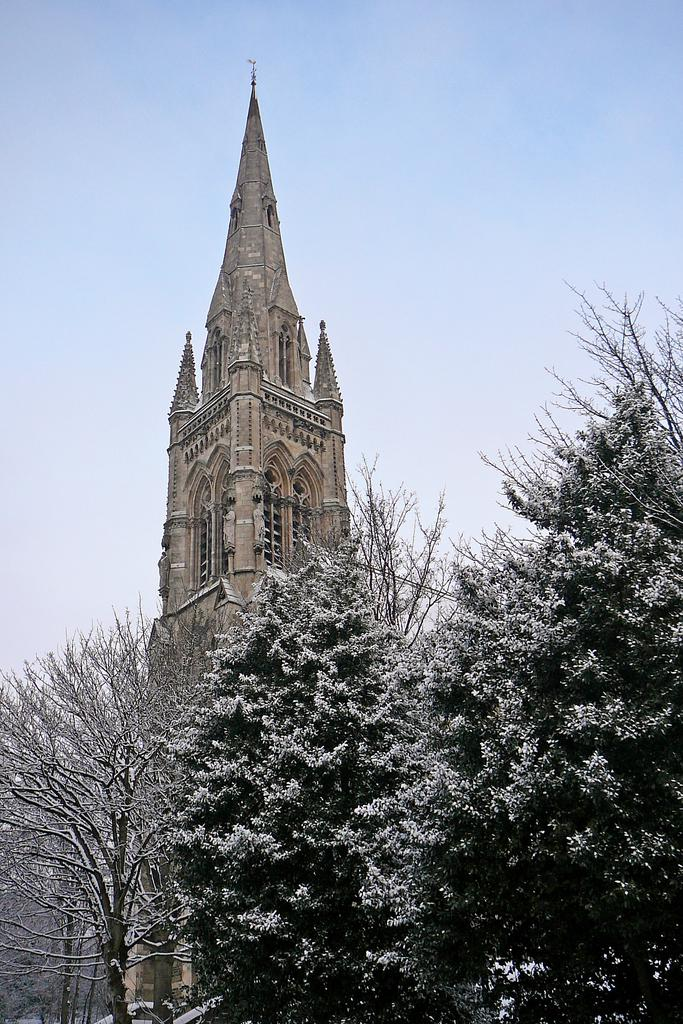What type of vegetation can be seen in the image? There are trees in the image. What structure is visible in the background? There is a building with windows in the background. What part of the natural environment is visible in the image? The sky is visible in the background. Can you see a fireman climbing the trees in the image? There is no fireman or climbing activity present in the image; it features trees and a building in the background. What type of mountain is visible in the image? There is no mountain present in the image; it features trees, a building, and the sky. 